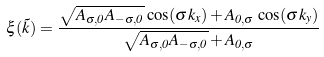<formula> <loc_0><loc_0><loc_500><loc_500>\xi ( \vec { k } ) = \frac { \sqrt { A _ { \sigma , 0 } A _ { - \sigma , 0 } } \, \cos ( \sigma k _ { x } ) + A _ { 0 , \sigma } \, \cos ( \sigma k _ { y } ) } { \sqrt { A _ { \sigma , 0 } A _ { - \sigma , 0 } } + A _ { 0 , \sigma } }</formula> 